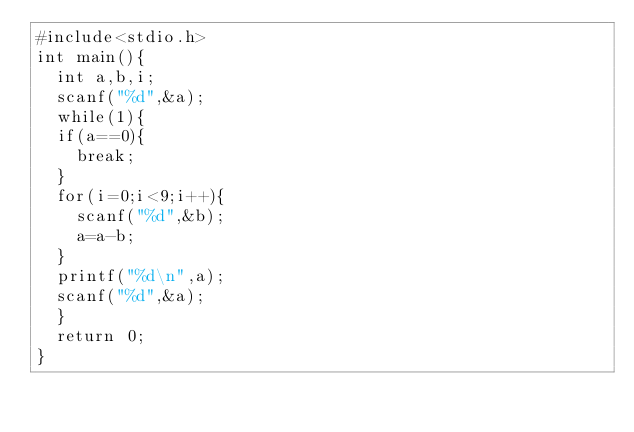Convert code to text. <code><loc_0><loc_0><loc_500><loc_500><_C_>#include<stdio.h>
int main(){
	int a,b,i;
	scanf("%d",&a);
	while(1){
	if(a==0){
		break;
	}
	for(i=0;i<9;i++){
		scanf("%d",&b);
		a=a-b;
	}
	printf("%d\n",a);
	scanf("%d",&a);
	}
	return 0;
}</code> 